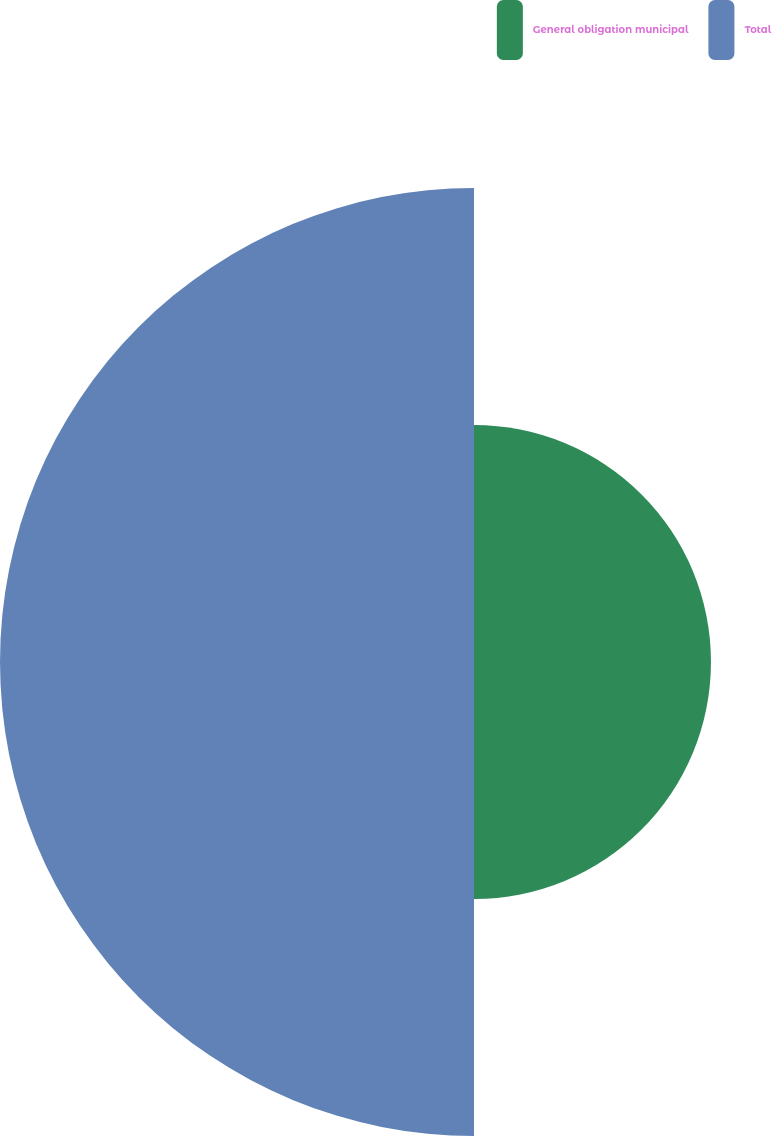<chart> <loc_0><loc_0><loc_500><loc_500><pie_chart><fcel>General obligation municipal<fcel>Total<nl><fcel>33.33%<fcel>66.67%<nl></chart> 